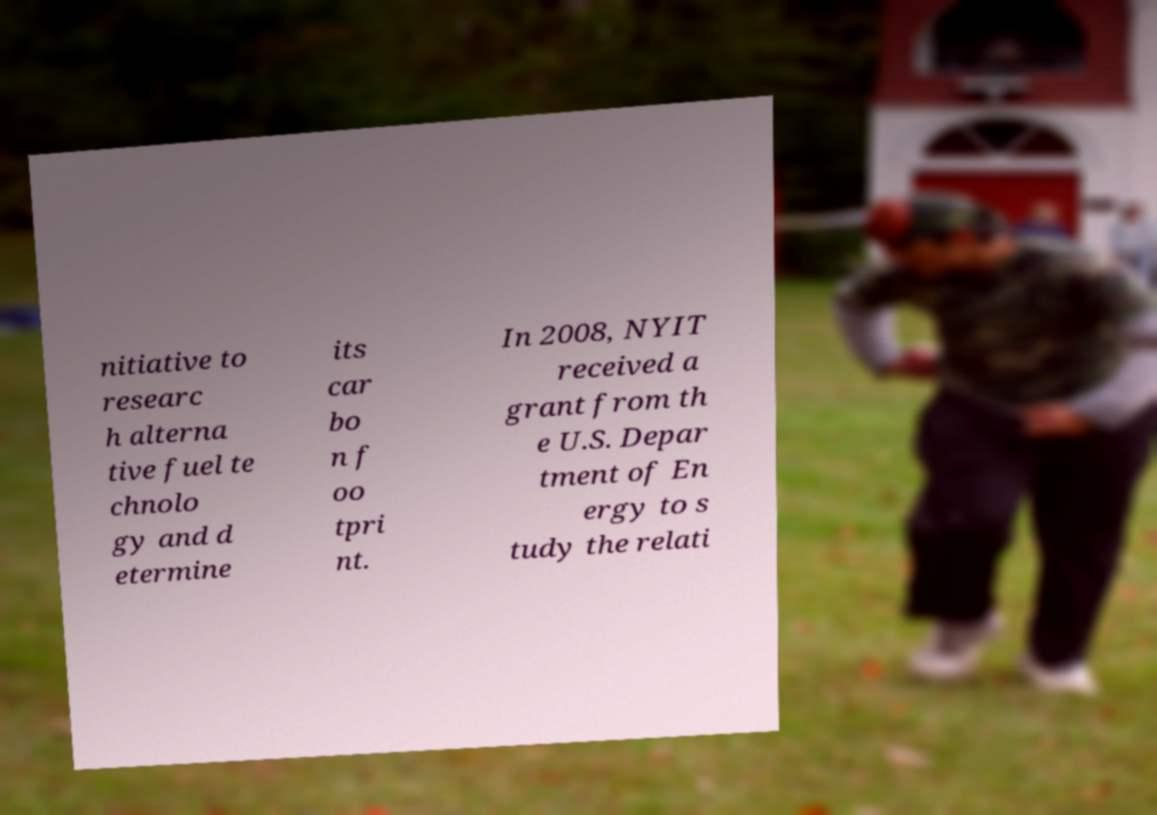For documentation purposes, I need the text within this image transcribed. Could you provide that? nitiative to researc h alterna tive fuel te chnolo gy and d etermine its car bo n f oo tpri nt. In 2008, NYIT received a grant from th e U.S. Depar tment of En ergy to s tudy the relati 